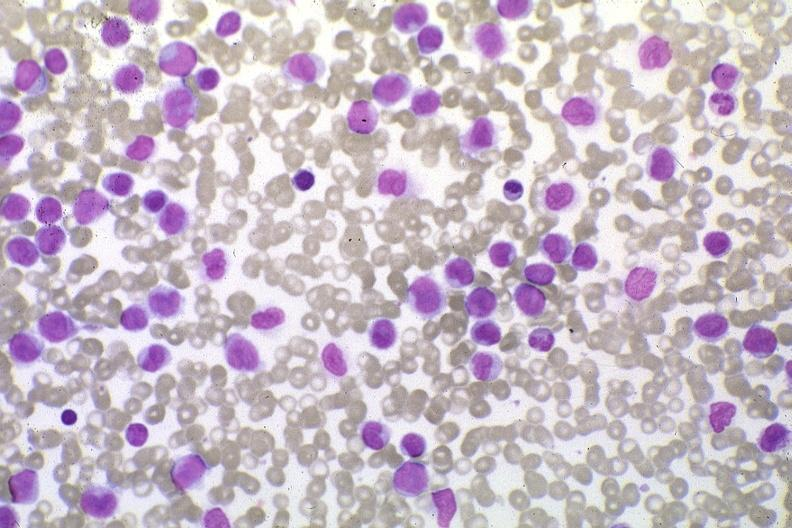do wrights stain pleomorphic leukemic cells in peripheral blood prior to therapy?
Answer the question using a single word or phrase. Yes 